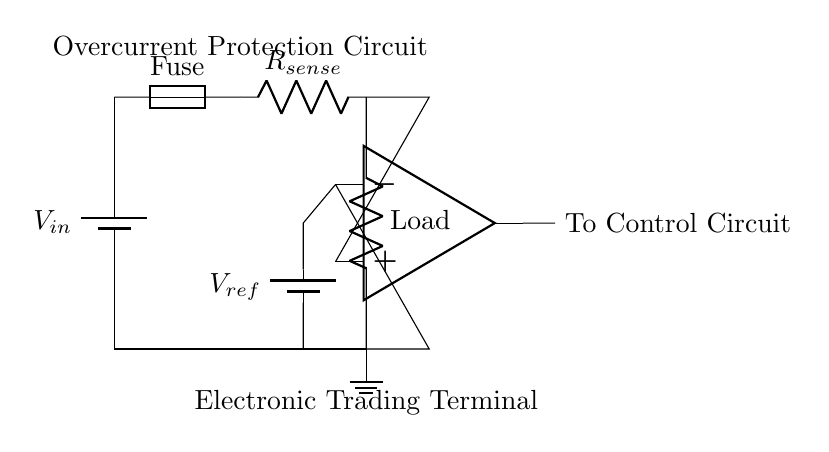What is the input voltage of this circuit? The input voltage is denoted as V_in, which is the voltage supplied to the circuit from the battery source at the top left corner.
Answer: V_in What type of resistor is shown in the circuit? The circuit includes a sense resistor labeled as R_sense, which is used to monitor the current passing through the circuit.
Answer: R_sense What is the purpose of the fuse in this circuit? The fuse acts as a protective device that interrupts the circuit when the current exceeds a certain threshold, preventing damage to the components.
Answer: Protection How many operational amplifier terminals are connected to the load? Two terminals are connected to the load: one terminal receives the voltage from the load and the other terminal connects to ground, providing the necessary reference for the op-amp operation.
Answer: Two What component connects the current sense resistor to the comparator? The current sense resistor connects directly to the non-inverting terminal of the operational amplifier (op-amp), which allows the comparison of the sensed voltage across the resistor with the reference voltage.
Answer: Current sense resistor What is the reference voltage in this circuit? The reference voltage is provided by a battery labeled as V_ref, which establishes the current threshold for the comparator's operation.
Answer: V_ref What does the output of the operational amplifier connect to? The output of the operational amplifier connects to the control circuit, indicating the action that needs to be taken when an overcurrent condition is detected.
Answer: Control Circuit 